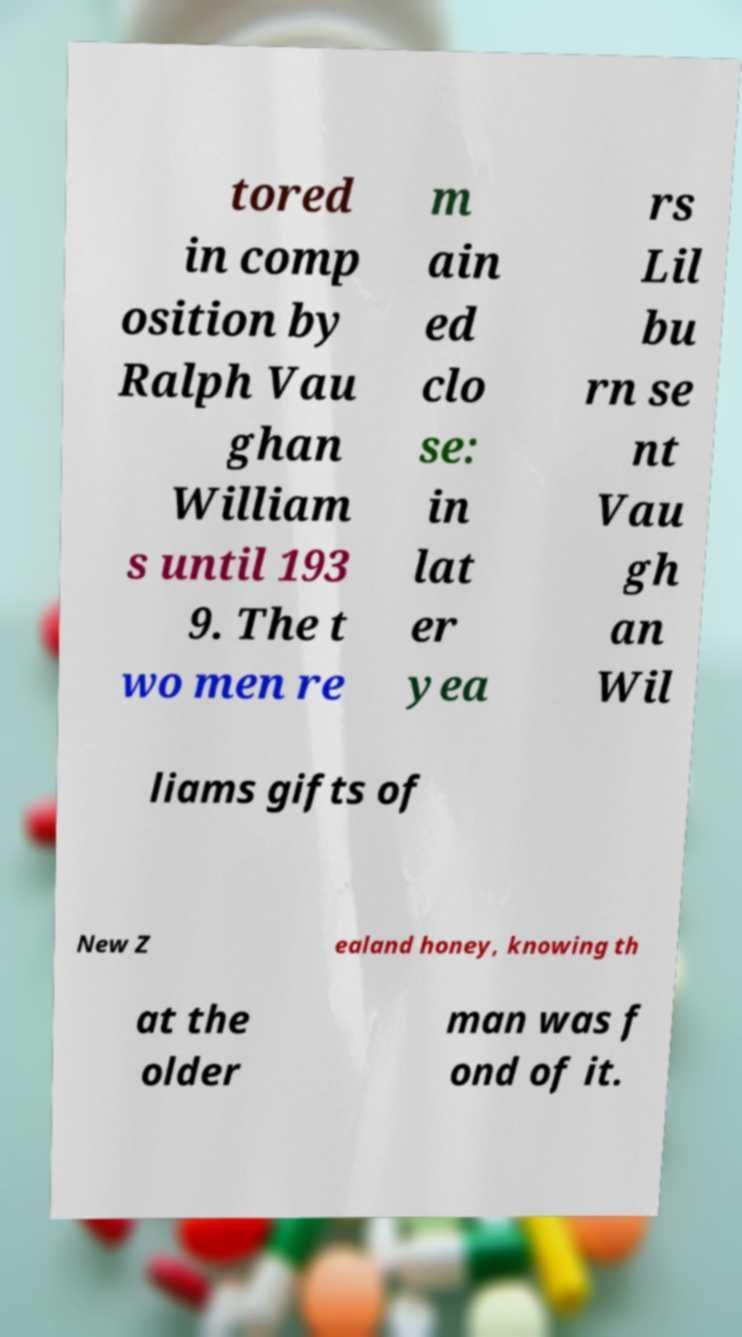There's text embedded in this image that I need extracted. Can you transcribe it verbatim? tored in comp osition by Ralph Vau ghan William s until 193 9. The t wo men re m ain ed clo se: in lat er yea rs Lil bu rn se nt Vau gh an Wil liams gifts of New Z ealand honey, knowing th at the older man was f ond of it. 